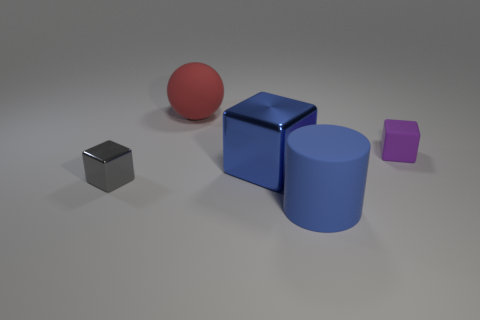Is the number of red blocks less than the number of big blue metallic blocks? yes 